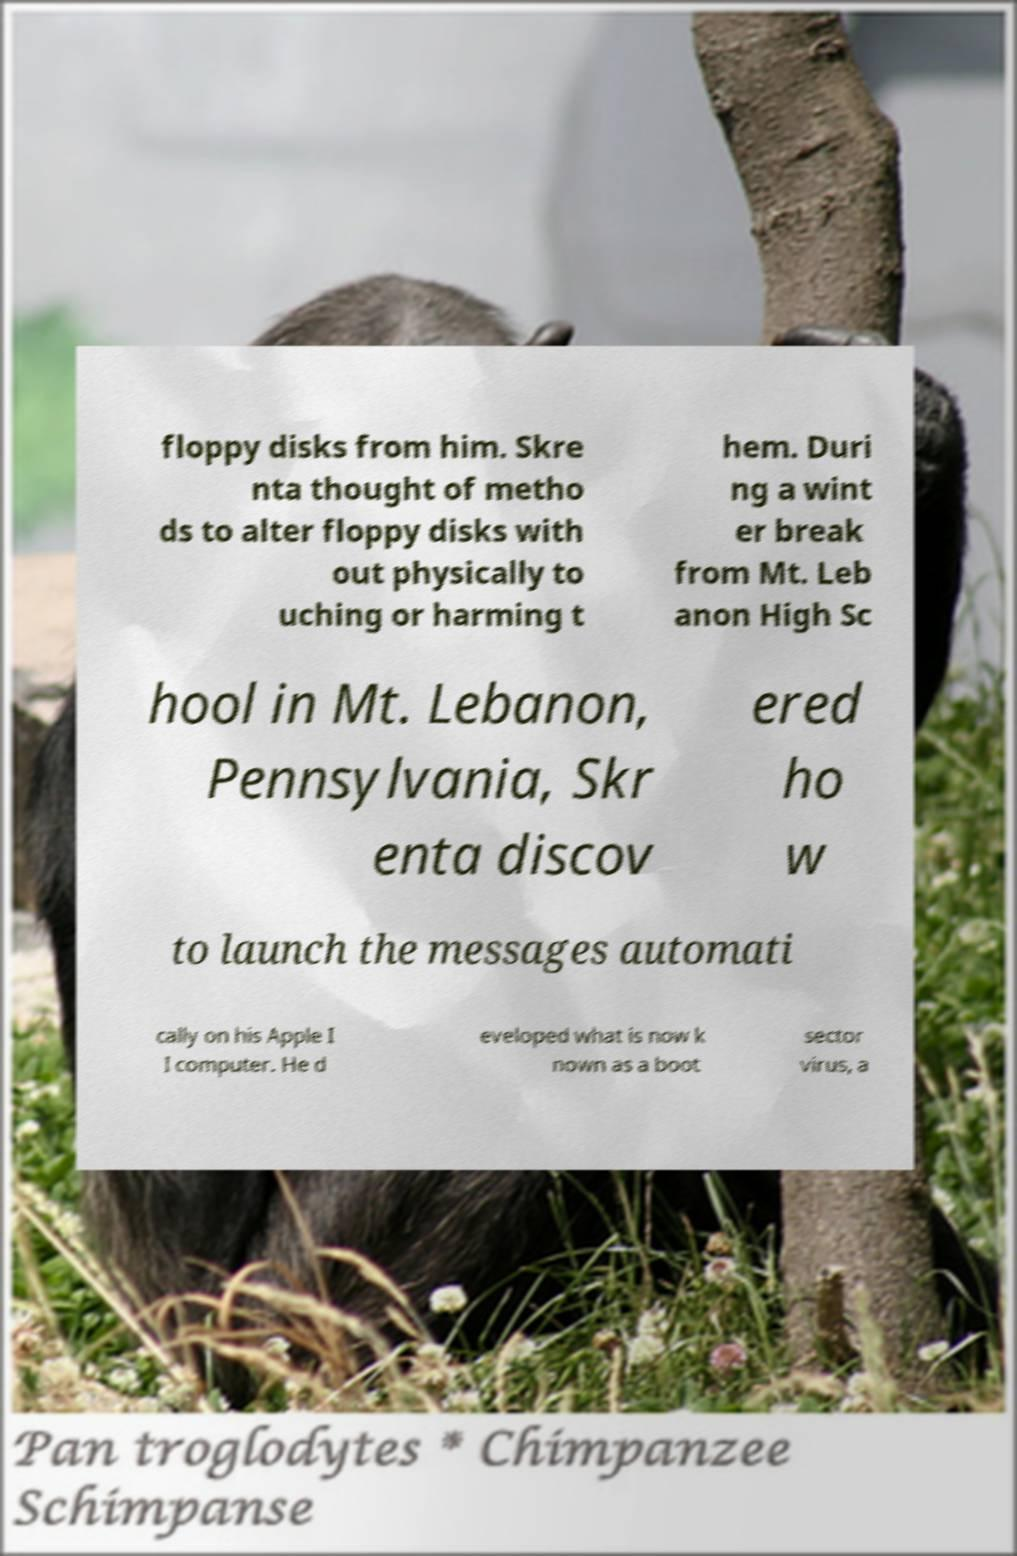Please identify and transcribe the text found in this image. floppy disks from him. Skre nta thought of metho ds to alter floppy disks with out physically to uching or harming t hem. Duri ng a wint er break from Mt. Leb anon High Sc hool in Mt. Lebanon, Pennsylvania, Skr enta discov ered ho w to launch the messages automati cally on his Apple I I computer. He d eveloped what is now k nown as a boot sector virus, a 